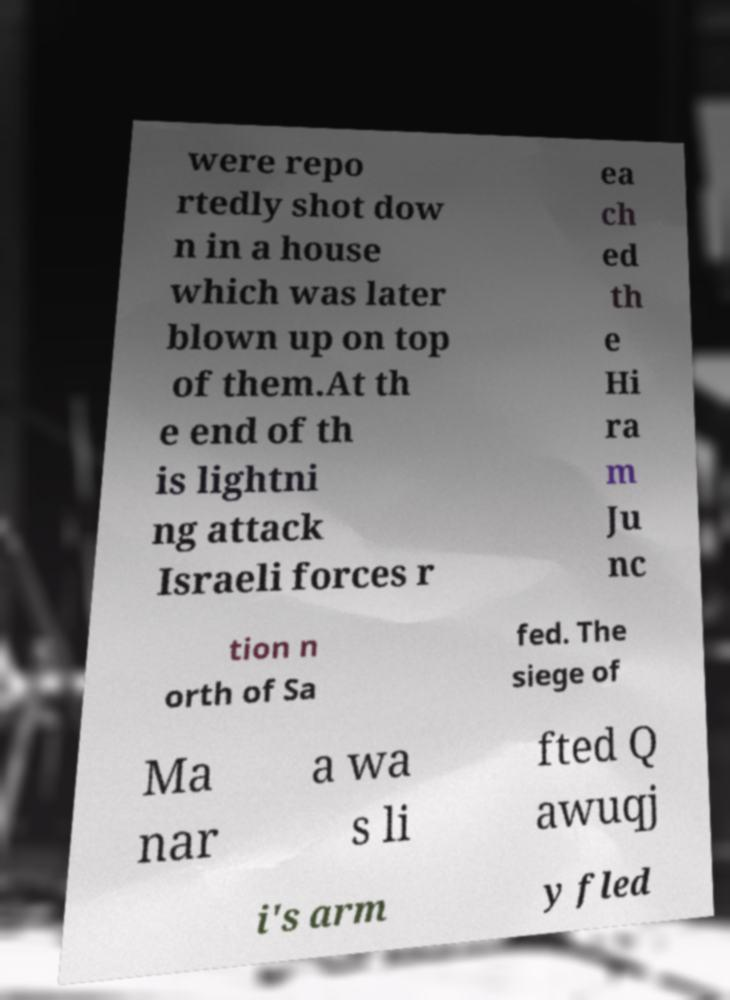What messages or text are displayed in this image? I need them in a readable, typed format. were repo rtedly shot dow n in a house which was later blown up on top of them.At th e end of th is lightni ng attack Israeli forces r ea ch ed th e Hi ra m Ju nc tion n orth of Sa fed. The siege of Ma nar a wa s li fted Q awuqj i's arm y fled 